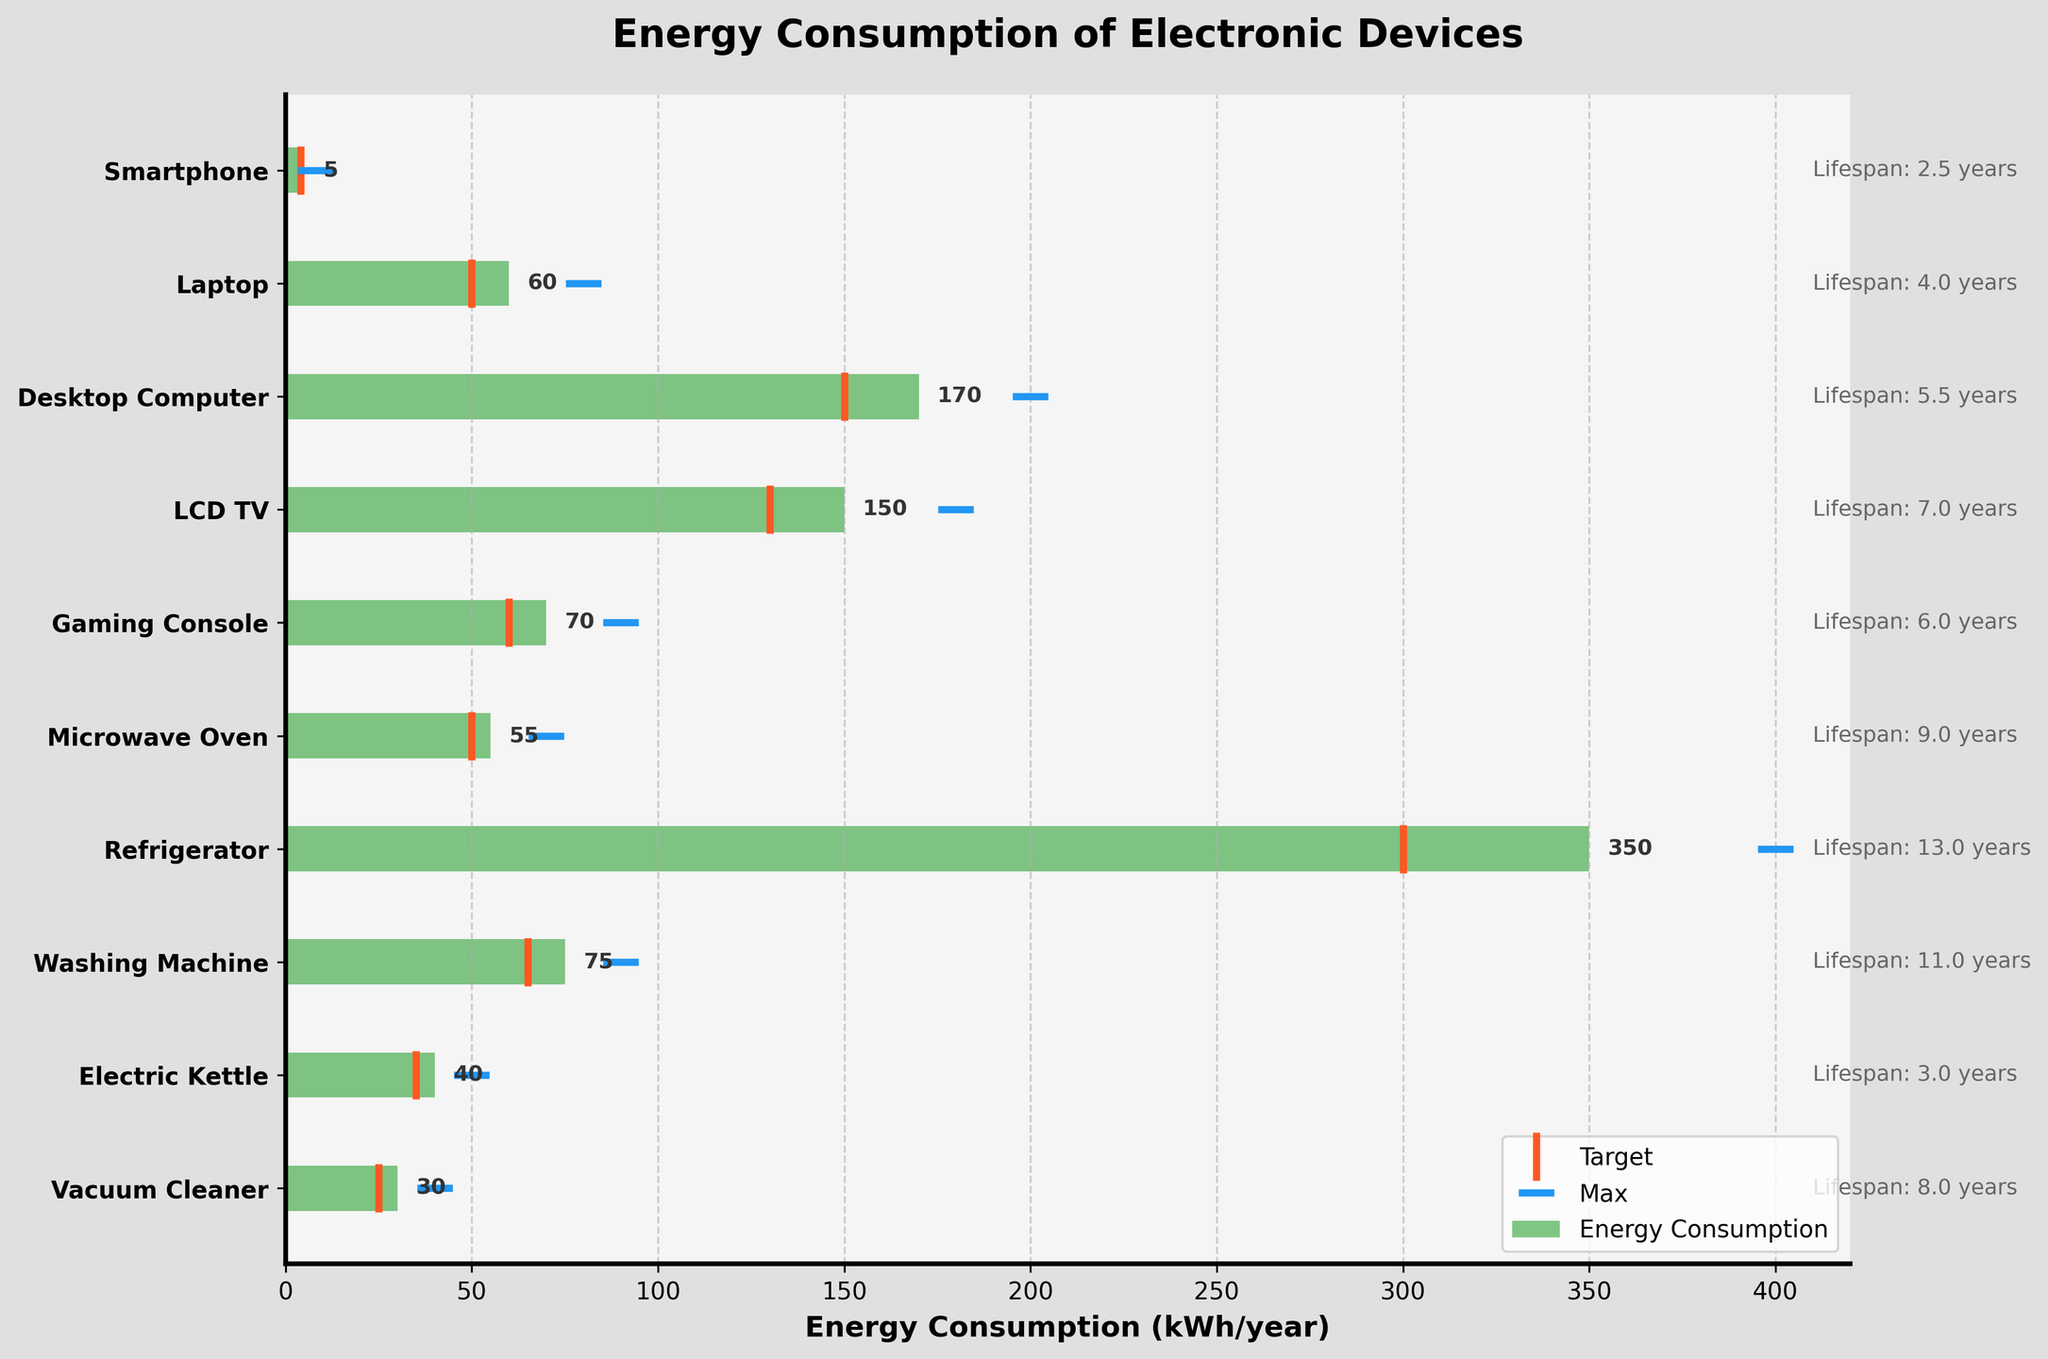What's the device with the highest energy consumption? The device with the highest energy consumption is the one with the largest bar in the plot. By observing the bars, the Refrigerator stands out with the highest value.
Answer: Refrigerator What is the average energy consumption of the Gaming Console over its lifespan? The average energy consumption over its lifespan is found by taking the given yearly consumption and multiplying by the lifespan: \( 70 \, \text{kWh/year} \times 6 \, \text{years} = 420 \, \text{kWh} \).
Answer: 420 kWh How does the energy consumption of a Microwave Oven compare to its target consumption? The energy consumption of the Microwave Oven is represented by the green bar, and the target consumption is shown by the vertical orange line. The green bar (55 kWh/year) exceeds the orange line (50 kWh/year).
Answer: 55 kWh exceeds 50 kWh Which device has the smallest deviation from its target consumption? By comparing the green bars to the vertical orange lines, the Electric Kettle appears to have the smallest deviation as its bar closely aligns with its target line at 35 kWh/year.
Answer: Electric Kettle What is the total energy consumption of a Laptop and a Smartphobe combined in a year? By adding the energy consumption values for both devices: \( 60 \, \text{kWh/year} + 5 \, \text{kWh/year} = 65 \, \text{kWh/year} \).
Answer: 65 kWh/year Which device has the largest margin between its actual and maximum consumption? To find the largest margin, we look for the device with the largest gap between the green bar (actual consumption) and the blue horizontal line (max consumption). The Desktop Computer shows the largest margin, with actual consumption of 170 kWh/year and max consumption of 200 kWh/year, yielding a margin of 30 kWh/year.
Answer: Desktop Computer In terms of lifespan, how does the Washing Machine compare to the Electric Kettle? The lifespan of the Washing Machine (11 years) is compared to the Electric Kettle (3 years). The Washing Machine lasts significantly longer.
Answer: Washing Machine lasts longer What does the target consumption marker represent on the chart? The target consumption marker is represented by the orange vertical line and indicates the ideal or recommended annual energy consumption for each device. This serves as a benchmark or goal for energy efficiency.
Answer: Ideal energy consumption List the devices that consume more than 100 kWh/year. Observing the chart, the devices with energy consumption bars extending beyond 100 kWh/year are the Desktop Computer, LCD TV, and Refrigerator.
Answer: Desktop Computer, LCD TV, Refrigerator 